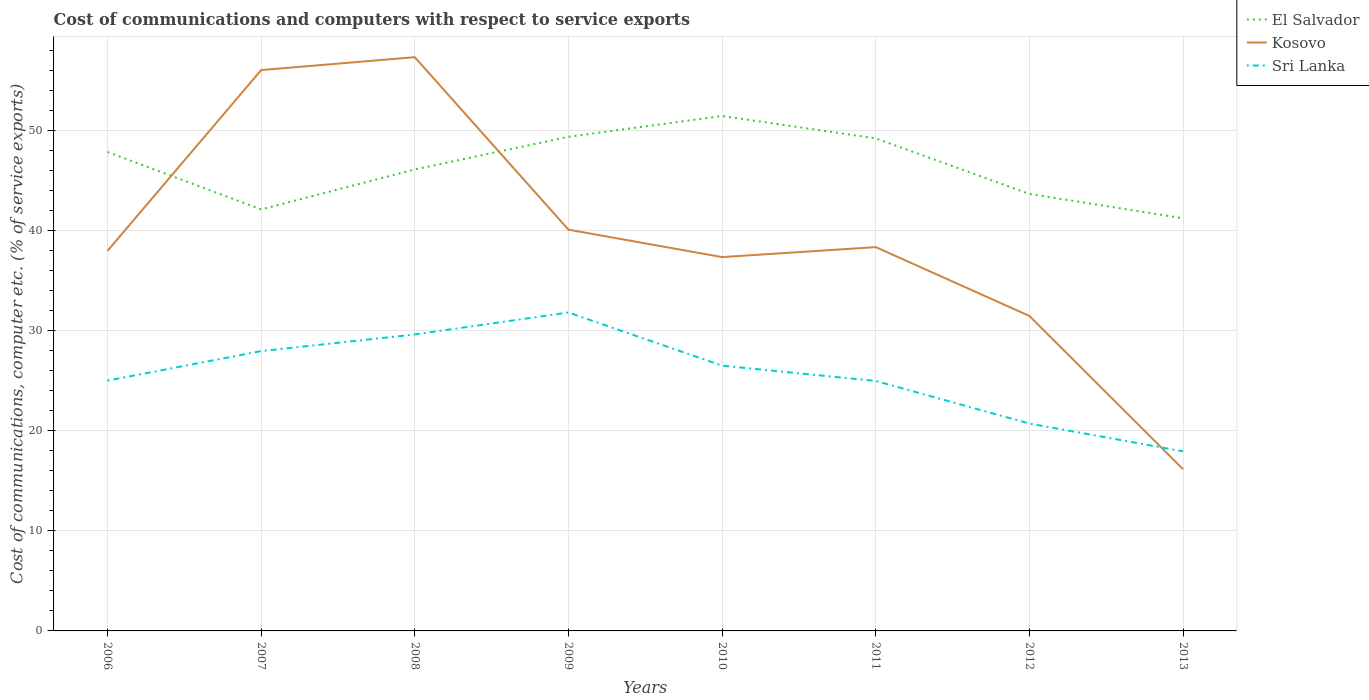Does the line corresponding to Sri Lanka intersect with the line corresponding to El Salvador?
Give a very brief answer. No. Across all years, what is the maximum cost of communications and computers in Sri Lanka?
Your response must be concise. 17.96. In which year was the cost of communications and computers in Kosovo maximum?
Offer a terse response. 2013. What is the total cost of communications and computers in El Salvador in the graph?
Give a very brief answer. 7.79. What is the difference between the highest and the second highest cost of communications and computers in Sri Lanka?
Ensure brevity in your answer.  13.88. What is the difference between the highest and the lowest cost of communications and computers in Kosovo?
Ensure brevity in your answer.  3. Is the cost of communications and computers in Kosovo strictly greater than the cost of communications and computers in El Salvador over the years?
Offer a terse response. No. Are the values on the major ticks of Y-axis written in scientific E-notation?
Provide a short and direct response. No. Does the graph contain any zero values?
Your answer should be compact. No. How many legend labels are there?
Ensure brevity in your answer.  3. How are the legend labels stacked?
Offer a terse response. Vertical. What is the title of the graph?
Provide a short and direct response. Cost of communications and computers with respect to service exports. Does "Oman" appear as one of the legend labels in the graph?
Your response must be concise. No. What is the label or title of the X-axis?
Provide a succinct answer. Years. What is the label or title of the Y-axis?
Your response must be concise. Cost of communications, computer etc. (% of service exports). What is the Cost of communications, computer etc. (% of service exports) in El Salvador in 2006?
Offer a very short reply. 47.89. What is the Cost of communications, computer etc. (% of service exports) in Kosovo in 2006?
Your answer should be compact. 38. What is the Cost of communications, computer etc. (% of service exports) in Sri Lanka in 2006?
Provide a succinct answer. 25.03. What is the Cost of communications, computer etc. (% of service exports) of El Salvador in 2007?
Give a very brief answer. 42.15. What is the Cost of communications, computer etc. (% of service exports) of Kosovo in 2007?
Provide a succinct answer. 56.09. What is the Cost of communications, computer etc. (% of service exports) in Sri Lanka in 2007?
Provide a short and direct response. 27.98. What is the Cost of communications, computer etc. (% of service exports) of El Salvador in 2008?
Your answer should be compact. 46.15. What is the Cost of communications, computer etc. (% of service exports) of Kosovo in 2008?
Ensure brevity in your answer.  57.37. What is the Cost of communications, computer etc. (% of service exports) of Sri Lanka in 2008?
Provide a succinct answer. 29.64. What is the Cost of communications, computer etc. (% of service exports) in El Salvador in 2009?
Offer a very short reply. 49.41. What is the Cost of communications, computer etc. (% of service exports) in Kosovo in 2009?
Your answer should be very brief. 40.12. What is the Cost of communications, computer etc. (% of service exports) of Sri Lanka in 2009?
Your response must be concise. 31.84. What is the Cost of communications, computer etc. (% of service exports) in El Salvador in 2010?
Provide a short and direct response. 51.49. What is the Cost of communications, computer etc. (% of service exports) of Kosovo in 2010?
Ensure brevity in your answer.  37.38. What is the Cost of communications, computer etc. (% of service exports) in Sri Lanka in 2010?
Provide a succinct answer. 26.53. What is the Cost of communications, computer etc. (% of service exports) of El Salvador in 2011?
Keep it short and to the point. 49.26. What is the Cost of communications, computer etc. (% of service exports) in Kosovo in 2011?
Make the answer very short. 38.38. What is the Cost of communications, computer etc. (% of service exports) of Sri Lanka in 2011?
Provide a succinct answer. 25. What is the Cost of communications, computer etc. (% of service exports) in El Salvador in 2012?
Provide a short and direct response. 43.7. What is the Cost of communications, computer etc. (% of service exports) of Kosovo in 2012?
Your answer should be compact. 31.5. What is the Cost of communications, computer etc. (% of service exports) of Sri Lanka in 2012?
Provide a short and direct response. 20.73. What is the Cost of communications, computer etc. (% of service exports) of El Salvador in 2013?
Give a very brief answer. 41.27. What is the Cost of communications, computer etc. (% of service exports) of Kosovo in 2013?
Ensure brevity in your answer.  16.17. What is the Cost of communications, computer etc. (% of service exports) of Sri Lanka in 2013?
Provide a succinct answer. 17.96. Across all years, what is the maximum Cost of communications, computer etc. (% of service exports) in El Salvador?
Your response must be concise. 51.49. Across all years, what is the maximum Cost of communications, computer etc. (% of service exports) in Kosovo?
Offer a very short reply. 57.37. Across all years, what is the maximum Cost of communications, computer etc. (% of service exports) in Sri Lanka?
Keep it short and to the point. 31.84. Across all years, what is the minimum Cost of communications, computer etc. (% of service exports) of El Salvador?
Ensure brevity in your answer.  41.27. Across all years, what is the minimum Cost of communications, computer etc. (% of service exports) in Kosovo?
Your answer should be very brief. 16.17. Across all years, what is the minimum Cost of communications, computer etc. (% of service exports) of Sri Lanka?
Offer a very short reply. 17.96. What is the total Cost of communications, computer etc. (% of service exports) of El Salvador in the graph?
Provide a short and direct response. 371.32. What is the total Cost of communications, computer etc. (% of service exports) in Kosovo in the graph?
Provide a short and direct response. 315.02. What is the total Cost of communications, computer etc. (% of service exports) of Sri Lanka in the graph?
Ensure brevity in your answer.  204.72. What is the difference between the Cost of communications, computer etc. (% of service exports) of El Salvador in 2006 and that in 2007?
Your response must be concise. 5.74. What is the difference between the Cost of communications, computer etc. (% of service exports) in Kosovo in 2006 and that in 2007?
Make the answer very short. -18.08. What is the difference between the Cost of communications, computer etc. (% of service exports) in Sri Lanka in 2006 and that in 2007?
Offer a terse response. -2.95. What is the difference between the Cost of communications, computer etc. (% of service exports) of El Salvador in 2006 and that in 2008?
Your response must be concise. 1.75. What is the difference between the Cost of communications, computer etc. (% of service exports) in Kosovo in 2006 and that in 2008?
Provide a short and direct response. -19.37. What is the difference between the Cost of communications, computer etc. (% of service exports) in Sri Lanka in 2006 and that in 2008?
Your answer should be compact. -4.61. What is the difference between the Cost of communications, computer etc. (% of service exports) of El Salvador in 2006 and that in 2009?
Offer a very short reply. -1.52. What is the difference between the Cost of communications, computer etc. (% of service exports) in Kosovo in 2006 and that in 2009?
Keep it short and to the point. -2.12. What is the difference between the Cost of communications, computer etc. (% of service exports) in Sri Lanka in 2006 and that in 2009?
Offer a terse response. -6.81. What is the difference between the Cost of communications, computer etc. (% of service exports) of El Salvador in 2006 and that in 2010?
Your answer should be very brief. -3.6. What is the difference between the Cost of communications, computer etc. (% of service exports) of Kosovo in 2006 and that in 2010?
Keep it short and to the point. 0.62. What is the difference between the Cost of communications, computer etc. (% of service exports) in Sri Lanka in 2006 and that in 2010?
Make the answer very short. -1.5. What is the difference between the Cost of communications, computer etc. (% of service exports) of El Salvador in 2006 and that in 2011?
Offer a terse response. -1.36. What is the difference between the Cost of communications, computer etc. (% of service exports) of Kosovo in 2006 and that in 2011?
Make the answer very short. -0.38. What is the difference between the Cost of communications, computer etc. (% of service exports) of Sri Lanka in 2006 and that in 2011?
Keep it short and to the point. 0.03. What is the difference between the Cost of communications, computer etc. (% of service exports) of El Salvador in 2006 and that in 2012?
Ensure brevity in your answer.  4.2. What is the difference between the Cost of communications, computer etc. (% of service exports) of Kosovo in 2006 and that in 2012?
Your response must be concise. 6.51. What is the difference between the Cost of communications, computer etc. (% of service exports) of Sri Lanka in 2006 and that in 2012?
Your response must be concise. 4.3. What is the difference between the Cost of communications, computer etc. (% of service exports) in El Salvador in 2006 and that in 2013?
Your answer should be very brief. 6.63. What is the difference between the Cost of communications, computer etc. (% of service exports) in Kosovo in 2006 and that in 2013?
Offer a very short reply. 21.83. What is the difference between the Cost of communications, computer etc. (% of service exports) in Sri Lanka in 2006 and that in 2013?
Your response must be concise. 7.07. What is the difference between the Cost of communications, computer etc. (% of service exports) in El Salvador in 2007 and that in 2008?
Your response must be concise. -4. What is the difference between the Cost of communications, computer etc. (% of service exports) of Kosovo in 2007 and that in 2008?
Your response must be concise. -1.29. What is the difference between the Cost of communications, computer etc. (% of service exports) of Sri Lanka in 2007 and that in 2008?
Offer a terse response. -1.66. What is the difference between the Cost of communications, computer etc. (% of service exports) in El Salvador in 2007 and that in 2009?
Keep it short and to the point. -7.26. What is the difference between the Cost of communications, computer etc. (% of service exports) of Kosovo in 2007 and that in 2009?
Your response must be concise. 15.96. What is the difference between the Cost of communications, computer etc. (% of service exports) of Sri Lanka in 2007 and that in 2009?
Your answer should be very brief. -3.86. What is the difference between the Cost of communications, computer etc. (% of service exports) in El Salvador in 2007 and that in 2010?
Make the answer very short. -9.34. What is the difference between the Cost of communications, computer etc. (% of service exports) of Kosovo in 2007 and that in 2010?
Offer a very short reply. 18.7. What is the difference between the Cost of communications, computer etc. (% of service exports) in Sri Lanka in 2007 and that in 2010?
Give a very brief answer. 1.46. What is the difference between the Cost of communications, computer etc. (% of service exports) of El Salvador in 2007 and that in 2011?
Offer a very short reply. -7.11. What is the difference between the Cost of communications, computer etc. (% of service exports) in Kosovo in 2007 and that in 2011?
Offer a very short reply. 17.7. What is the difference between the Cost of communications, computer etc. (% of service exports) in Sri Lanka in 2007 and that in 2011?
Your answer should be compact. 2.99. What is the difference between the Cost of communications, computer etc. (% of service exports) of El Salvador in 2007 and that in 2012?
Give a very brief answer. -1.55. What is the difference between the Cost of communications, computer etc. (% of service exports) in Kosovo in 2007 and that in 2012?
Your response must be concise. 24.59. What is the difference between the Cost of communications, computer etc. (% of service exports) in Sri Lanka in 2007 and that in 2012?
Your answer should be compact. 7.25. What is the difference between the Cost of communications, computer etc. (% of service exports) in El Salvador in 2007 and that in 2013?
Offer a very short reply. 0.88. What is the difference between the Cost of communications, computer etc. (% of service exports) of Kosovo in 2007 and that in 2013?
Your answer should be compact. 39.91. What is the difference between the Cost of communications, computer etc. (% of service exports) of Sri Lanka in 2007 and that in 2013?
Your response must be concise. 10.02. What is the difference between the Cost of communications, computer etc. (% of service exports) in El Salvador in 2008 and that in 2009?
Keep it short and to the point. -3.26. What is the difference between the Cost of communications, computer etc. (% of service exports) of Kosovo in 2008 and that in 2009?
Keep it short and to the point. 17.25. What is the difference between the Cost of communications, computer etc. (% of service exports) in Sri Lanka in 2008 and that in 2009?
Offer a very short reply. -2.2. What is the difference between the Cost of communications, computer etc. (% of service exports) in El Salvador in 2008 and that in 2010?
Your answer should be very brief. -5.35. What is the difference between the Cost of communications, computer etc. (% of service exports) in Kosovo in 2008 and that in 2010?
Your answer should be compact. 19.99. What is the difference between the Cost of communications, computer etc. (% of service exports) in Sri Lanka in 2008 and that in 2010?
Make the answer very short. 3.12. What is the difference between the Cost of communications, computer etc. (% of service exports) of El Salvador in 2008 and that in 2011?
Provide a succinct answer. -3.11. What is the difference between the Cost of communications, computer etc. (% of service exports) of Kosovo in 2008 and that in 2011?
Ensure brevity in your answer.  18.99. What is the difference between the Cost of communications, computer etc. (% of service exports) of Sri Lanka in 2008 and that in 2011?
Keep it short and to the point. 4.65. What is the difference between the Cost of communications, computer etc. (% of service exports) in El Salvador in 2008 and that in 2012?
Your response must be concise. 2.45. What is the difference between the Cost of communications, computer etc. (% of service exports) of Kosovo in 2008 and that in 2012?
Offer a very short reply. 25.88. What is the difference between the Cost of communications, computer etc. (% of service exports) of Sri Lanka in 2008 and that in 2012?
Your response must be concise. 8.91. What is the difference between the Cost of communications, computer etc. (% of service exports) in El Salvador in 2008 and that in 2013?
Keep it short and to the point. 4.88. What is the difference between the Cost of communications, computer etc. (% of service exports) of Kosovo in 2008 and that in 2013?
Ensure brevity in your answer.  41.2. What is the difference between the Cost of communications, computer etc. (% of service exports) of Sri Lanka in 2008 and that in 2013?
Offer a terse response. 11.68. What is the difference between the Cost of communications, computer etc. (% of service exports) of El Salvador in 2009 and that in 2010?
Provide a succinct answer. -2.08. What is the difference between the Cost of communications, computer etc. (% of service exports) of Kosovo in 2009 and that in 2010?
Ensure brevity in your answer.  2.74. What is the difference between the Cost of communications, computer etc. (% of service exports) in Sri Lanka in 2009 and that in 2010?
Your response must be concise. 5.32. What is the difference between the Cost of communications, computer etc. (% of service exports) of El Salvador in 2009 and that in 2011?
Provide a succinct answer. 0.15. What is the difference between the Cost of communications, computer etc. (% of service exports) of Kosovo in 2009 and that in 2011?
Keep it short and to the point. 1.74. What is the difference between the Cost of communications, computer etc. (% of service exports) of Sri Lanka in 2009 and that in 2011?
Your answer should be compact. 6.85. What is the difference between the Cost of communications, computer etc. (% of service exports) of El Salvador in 2009 and that in 2012?
Provide a short and direct response. 5.71. What is the difference between the Cost of communications, computer etc. (% of service exports) of Kosovo in 2009 and that in 2012?
Provide a short and direct response. 8.63. What is the difference between the Cost of communications, computer etc. (% of service exports) of Sri Lanka in 2009 and that in 2012?
Your answer should be very brief. 11.11. What is the difference between the Cost of communications, computer etc. (% of service exports) in El Salvador in 2009 and that in 2013?
Give a very brief answer. 8.14. What is the difference between the Cost of communications, computer etc. (% of service exports) of Kosovo in 2009 and that in 2013?
Offer a very short reply. 23.95. What is the difference between the Cost of communications, computer etc. (% of service exports) of Sri Lanka in 2009 and that in 2013?
Provide a succinct answer. 13.88. What is the difference between the Cost of communications, computer etc. (% of service exports) of El Salvador in 2010 and that in 2011?
Provide a short and direct response. 2.24. What is the difference between the Cost of communications, computer etc. (% of service exports) in Kosovo in 2010 and that in 2011?
Offer a terse response. -1. What is the difference between the Cost of communications, computer etc. (% of service exports) in Sri Lanka in 2010 and that in 2011?
Give a very brief answer. 1.53. What is the difference between the Cost of communications, computer etc. (% of service exports) in El Salvador in 2010 and that in 2012?
Offer a terse response. 7.79. What is the difference between the Cost of communications, computer etc. (% of service exports) of Kosovo in 2010 and that in 2012?
Make the answer very short. 5.89. What is the difference between the Cost of communications, computer etc. (% of service exports) of Sri Lanka in 2010 and that in 2012?
Your answer should be very brief. 5.79. What is the difference between the Cost of communications, computer etc. (% of service exports) of El Salvador in 2010 and that in 2013?
Keep it short and to the point. 10.23. What is the difference between the Cost of communications, computer etc. (% of service exports) of Kosovo in 2010 and that in 2013?
Your answer should be very brief. 21.21. What is the difference between the Cost of communications, computer etc. (% of service exports) of Sri Lanka in 2010 and that in 2013?
Provide a succinct answer. 8.57. What is the difference between the Cost of communications, computer etc. (% of service exports) in El Salvador in 2011 and that in 2012?
Your answer should be compact. 5.56. What is the difference between the Cost of communications, computer etc. (% of service exports) of Kosovo in 2011 and that in 2012?
Ensure brevity in your answer.  6.88. What is the difference between the Cost of communications, computer etc. (% of service exports) of Sri Lanka in 2011 and that in 2012?
Keep it short and to the point. 4.26. What is the difference between the Cost of communications, computer etc. (% of service exports) of El Salvador in 2011 and that in 2013?
Your answer should be very brief. 7.99. What is the difference between the Cost of communications, computer etc. (% of service exports) in Kosovo in 2011 and that in 2013?
Offer a very short reply. 22.21. What is the difference between the Cost of communications, computer etc. (% of service exports) in Sri Lanka in 2011 and that in 2013?
Offer a terse response. 7.04. What is the difference between the Cost of communications, computer etc. (% of service exports) of El Salvador in 2012 and that in 2013?
Offer a very short reply. 2.43. What is the difference between the Cost of communications, computer etc. (% of service exports) of Kosovo in 2012 and that in 2013?
Give a very brief answer. 15.32. What is the difference between the Cost of communications, computer etc. (% of service exports) of Sri Lanka in 2012 and that in 2013?
Offer a terse response. 2.77. What is the difference between the Cost of communications, computer etc. (% of service exports) in El Salvador in 2006 and the Cost of communications, computer etc. (% of service exports) in Kosovo in 2007?
Offer a very short reply. -8.19. What is the difference between the Cost of communications, computer etc. (% of service exports) of El Salvador in 2006 and the Cost of communications, computer etc. (% of service exports) of Sri Lanka in 2007?
Provide a short and direct response. 19.91. What is the difference between the Cost of communications, computer etc. (% of service exports) of Kosovo in 2006 and the Cost of communications, computer etc. (% of service exports) of Sri Lanka in 2007?
Offer a terse response. 10.02. What is the difference between the Cost of communications, computer etc. (% of service exports) in El Salvador in 2006 and the Cost of communications, computer etc. (% of service exports) in Kosovo in 2008?
Your answer should be very brief. -9.48. What is the difference between the Cost of communications, computer etc. (% of service exports) of El Salvador in 2006 and the Cost of communications, computer etc. (% of service exports) of Sri Lanka in 2008?
Your response must be concise. 18.25. What is the difference between the Cost of communications, computer etc. (% of service exports) in Kosovo in 2006 and the Cost of communications, computer etc. (% of service exports) in Sri Lanka in 2008?
Your answer should be compact. 8.36. What is the difference between the Cost of communications, computer etc. (% of service exports) in El Salvador in 2006 and the Cost of communications, computer etc. (% of service exports) in Kosovo in 2009?
Provide a succinct answer. 7.77. What is the difference between the Cost of communications, computer etc. (% of service exports) of El Salvador in 2006 and the Cost of communications, computer etc. (% of service exports) of Sri Lanka in 2009?
Make the answer very short. 16.05. What is the difference between the Cost of communications, computer etc. (% of service exports) of Kosovo in 2006 and the Cost of communications, computer etc. (% of service exports) of Sri Lanka in 2009?
Offer a very short reply. 6.16. What is the difference between the Cost of communications, computer etc. (% of service exports) in El Salvador in 2006 and the Cost of communications, computer etc. (% of service exports) in Kosovo in 2010?
Make the answer very short. 10.51. What is the difference between the Cost of communications, computer etc. (% of service exports) in El Salvador in 2006 and the Cost of communications, computer etc. (% of service exports) in Sri Lanka in 2010?
Provide a short and direct response. 21.37. What is the difference between the Cost of communications, computer etc. (% of service exports) of Kosovo in 2006 and the Cost of communications, computer etc. (% of service exports) of Sri Lanka in 2010?
Your answer should be compact. 11.48. What is the difference between the Cost of communications, computer etc. (% of service exports) in El Salvador in 2006 and the Cost of communications, computer etc. (% of service exports) in Kosovo in 2011?
Offer a terse response. 9.51. What is the difference between the Cost of communications, computer etc. (% of service exports) in El Salvador in 2006 and the Cost of communications, computer etc. (% of service exports) in Sri Lanka in 2011?
Ensure brevity in your answer.  22.9. What is the difference between the Cost of communications, computer etc. (% of service exports) in Kosovo in 2006 and the Cost of communications, computer etc. (% of service exports) in Sri Lanka in 2011?
Offer a very short reply. 13.01. What is the difference between the Cost of communications, computer etc. (% of service exports) of El Salvador in 2006 and the Cost of communications, computer etc. (% of service exports) of Kosovo in 2012?
Provide a succinct answer. 16.4. What is the difference between the Cost of communications, computer etc. (% of service exports) of El Salvador in 2006 and the Cost of communications, computer etc. (% of service exports) of Sri Lanka in 2012?
Offer a terse response. 27.16. What is the difference between the Cost of communications, computer etc. (% of service exports) in Kosovo in 2006 and the Cost of communications, computer etc. (% of service exports) in Sri Lanka in 2012?
Your response must be concise. 17.27. What is the difference between the Cost of communications, computer etc. (% of service exports) of El Salvador in 2006 and the Cost of communications, computer etc. (% of service exports) of Kosovo in 2013?
Offer a very short reply. 31.72. What is the difference between the Cost of communications, computer etc. (% of service exports) in El Salvador in 2006 and the Cost of communications, computer etc. (% of service exports) in Sri Lanka in 2013?
Provide a short and direct response. 29.93. What is the difference between the Cost of communications, computer etc. (% of service exports) in Kosovo in 2006 and the Cost of communications, computer etc. (% of service exports) in Sri Lanka in 2013?
Make the answer very short. 20.04. What is the difference between the Cost of communications, computer etc. (% of service exports) of El Salvador in 2007 and the Cost of communications, computer etc. (% of service exports) of Kosovo in 2008?
Keep it short and to the point. -15.22. What is the difference between the Cost of communications, computer etc. (% of service exports) in El Salvador in 2007 and the Cost of communications, computer etc. (% of service exports) in Sri Lanka in 2008?
Keep it short and to the point. 12.51. What is the difference between the Cost of communications, computer etc. (% of service exports) of Kosovo in 2007 and the Cost of communications, computer etc. (% of service exports) of Sri Lanka in 2008?
Your response must be concise. 26.44. What is the difference between the Cost of communications, computer etc. (% of service exports) of El Salvador in 2007 and the Cost of communications, computer etc. (% of service exports) of Kosovo in 2009?
Offer a very short reply. 2.03. What is the difference between the Cost of communications, computer etc. (% of service exports) in El Salvador in 2007 and the Cost of communications, computer etc. (% of service exports) in Sri Lanka in 2009?
Provide a short and direct response. 10.31. What is the difference between the Cost of communications, computer etc. (% of service exports) in Kosovo in 2007 and the Cost of communications, computer etc. (% of service exports) in Sri Lanka in 2009?
Offer a terse response. 24.24. What is the difference between the Cost of communications, computer etc. (% of service exports) in El Salvador in 2007 and the Cost of communications, computer etc. (% of service exports) in Kosovo in 2010?
Keep it short and to the point. 4.77. What is the difference between the Cost of communications, computer etc. (% of service exports) of El Salvador in 2007 and the Cost of communications, computer etc. (% of service exports) of Sri Lanka in 2010?
Ensure brevity in your answer.  15.62. What is the difference between the Cost of communications, computer etc. (% of service exports) in Kosovo in 2007 and the Cost of communications, computer etc. (% of service exports) in Sri Lanka in 2010?
Your answer should be very brief. 29.56. What is the difference between the Cost of communications, computer etc. (% of service exports) of El Salvador in 2007 and the Cost of communications, computer etc. (% of service exports) of Kosovo in 2011?
Your answer should be compact. 3.77. What is the difference between the Cost of communications, computer etc. (% of service exports) in El Salvador in 2007 and the Cost of communications, computer etc. (% of service exports) in Sri Lanka in 2011?
Keep it short and to the point. 17.15. What is the difference between the Cost of communications, computer etc. (% of service exports) of Kosovo in 2007 and the Cost of communications, computer etc. (% of service exports) of Sri Lanka in 2011?
Offer a terse response. 31.09. What is the difference between the Cost of communications, computer etc. (% of service exports) in El Salvador in 2007 and the Cost of communications, computer etc. (% of service exports) in Kosovo in 2012?
Offer a very short reply. 10.65. What is the difference between the Cost of communications, computer etc. (% of service exports) in El Salvador in 2007 and the Cost of communications, computer etc. (% of service exports) in Sri Lanka in 2012?
Offer a terse response. 21.42. What is the difference between the Cost of communications, computer etc. (% of service exports) of Kosovo in 2007 and the Cost of communications, computer etc. (% of service exports) of Sri Lanka in 2012?
Provide a short and direct response. 35.35. What is the difference between the Cost of communications, computer etc. (% of service exports) of El Salvador in 2007 and the Cost of communications, computer etc. (% of service exports) of Kosovo in 2013?
Your response must be concise. 25.98. What is the difference between the Cost of communications, computer etc. (% of service exports) of El Salvador in 2007 and the Cost of communications, computer etc. (% of service exports) of Sri Lanka in 2013?
Your answer should be compact. 24.19. What is the difference between the Cost of communications, computer etc. (% of service exports) of Kosovo in 2007 and the Cost of communications, computer etc. (% of service exports) of Sri Lanka in 2013?
Offer a very short reply. 38.12. What is the difference between the Cost of communications, computer etc. (% of service exports) in El Salvador in 2008 and the Cost of communications, computer etc. (% of service exports) in Kosovo in 2009?
Provide a succinct answer. 6.02. What is the difference between the Cost of communications, computer etc. (% of service exports) of El Salvador in 2008 and the Cost of communications, computer etc. (% of service exports) of Sri Lanka in 2009?
Provide a short and direct response. 14.3. What is the difference between the Cost of communications, computer etc. (% of service exports) of Kosovo in 2008 and the Cost of communications, computer etc. (% of service exports) of Sri Lanka in 2009?
Your answer should be compact. 25.53. What is the difference between the Cost of communications, computer etc. (% of service exports) in El Salvador in 2008 and the Cost of communications, computer etc. (% of service exports) in Kosovo in 2010?
Offer a terse response. 8.76. What is the difference between the Cost of communications, computer etc. (% of service exports) of El Salvador in 2008 and the Cost of communications, computer etc. (% of service exports) of Sri Lanka in 2010?
Offer a terse response. 19.62. What is the difference between the Cost of communications, computer etc. (% of service exports) of Kosovo in 2008 and the Cost of communications, computer etc. (% of service exports) of Sri Lanka in 2010?
Give a very brief answer. 30.85. What is the difference between the Cost of communications, computer etc. (% of service exports) in El Salvador in 2008 and the Cost of communications, computer etc. (% of service exports) in Kosovo in 2011?
Give a very brief answer. 7.77. What is the difference between the Cost of communications, computer etc. (% of service exports) of El Salvador in 2008 and the Cost of communications, computer etc. (% of service exports) of Sri Lanka in 2011?
Your response must be concise. 21.15. What is the difference between the Cost of communications, computer etc. (% of service exports) of Kosovo in 2008 and the Cost of communications, computer etc. (% of service exports) of Sri Lanka in 2011?
Keep it short and to the point. 32.38. What is the difference between the Cost of communications, computer etc. (% of service exports) of El Salvador in 2008 and the Cost of communications, computer etc. (% of service exports) of Kosovo in 2012?
Provide a short and direct response. 14.65. What is the difference between the Cost of communications, computer etc. (% of service exports) of El Salvador in 2008 and the Cost of communications, computer etc. (% of service exports) of Sri Lanka in 2012?
Your answer should be very brief. 25.41. What is the difference between the Cost of communications, computer etc. (% of service exports) in Kosovo in 2008 and the Cost of communications, computer etc. (% of service exports) in Sri Lanka in 2012?
Provide a short and direct response. 36.64. What is the difference between the Cost of communications, computer etc. (% of service exports) of El Salvador in 2008 and the Cost of communications, computer etc. (% of service exports) of Kosovo in 2013?
Provide a succinct answer. 29.97. What is the difference between the Cost of communications, computer etc. (% of service exports) of El Salvador in 2008 and the Cost of communications, computer etc. (% of service exports) of Sri Lanka in 2013?
Ensure brevity in your answer.  28.19. What is the difference between the Cost of communications, computer etc. (% of service exports) in Kosovo in 2008 and the Cost of communications, computer etc. (% of service exports) in Sri Lanka in 2013?
Make the answer very short. 39.41. What is the difference between the Cost of communications, computer etc. (% of service exports) in El Salvador in 2009 and the Cost of communications, computer etc. (% of service exports) in Kosovo in 2010?
Your answer should be compact. 12.03. What is the difference between the Cost of communications, computer etc. (% of service exports) of El Salvador in 2009 and the Cost of communications, computer etc. (% of service exports) of Sri Lanka in 2010?
Offer a terse response. 22.88. What is the difference between the Cost of communications, computer etc. (% of service exports) in Kosovo in 2009 and the Cost of communications, computer etc. (% of service exports) in Sri Lanka in 2010?
Provide a succinct answer. 13.6. What is the difference between the Cost of communications, computer etc. (% of service exports) in El Salvador in 2009 and the Cost of communications, computer etc. (% of service exports) in Kosovo in 2011?
Provide a short and direct response. 11.03. What is the difference between the Cost of communications, computer etc. (% of service exports) of El Salvador in 2009 and the Cost of communications, computer etc. (% of service exports) of Sri Lanka in 2011?
Offer a terse response. 24.41. What is the difference between the Cost of communications, computer etc. (% of service exports) of Kosovo in 2009 and the Cost of communications, computer etc. (% of service exports) of Sri Lanka in 2011?
Give a very brief answer. 15.13. What is the difference between the Cost of communications, computer etc. (% of service exports) of El Salvador in 2009 and the Cost of communications, computer etc. (% of service exports) of Kosovo in 2012?
Offer a very short reply. 17.91. What is the difference between the Cost of communications, computer etc. (% of service exports) in El Salvador in 2009 and the Cost of communications, computer etc. (% of service exports) in Sri Lanka in 2012?
Your answer should be compact. 28.68. What is the difference between the Cost of communications, computer etc. (% of service exports) in Kosovo in 2009 and the Cost of communications, computer etc. (% of service exports) in Sri Lanka in 2012?
Make the answer very short. 19.39. What is the difference between the Cost of communications, computer etc. (% of service exports) of El Salvador in 2009 and the Cost of communications, computer etc. (% of service exports) of Kosovo in 2013?
Offer a terse response. 33.24. What is the difference between the Cost of communications, computer etc. (% of service exports) of El Salvador in 2009 and the Cost of communications, computer etc. (% of service exports) of Sri Lanka in 2013?
Offer a terse response. 31.45. What is the difference between the Cost of communications, computer etc. (% of service exports) in Kosovo in 2009 and the Cost of communications, computer etc. (% of service exports) in Sri Lanka in 2013?
Provide a short and direct response. 22.16. What is the difference between the Cost of communications, computer etc. (% of service exports) in El Salvador in 2010 and the Cost of communications, computer etc. (% of service exports) in Kosovo in 2011?
Give a very brief answer. 13.11. What is the difference between the Cost of communications, computer etc. (% of service exports) in El Salvador in 2010 and the Cost of communications, computer etc. (% of service exports) in Sri Lanka in 2011?
Provide a short and direct response. 26.5. What is the difference between the Cost of communications, computer etc. (% of service exports) of Kosovo in 2010 and the Cost of communications, computer etc. (% of service exports) of Sri Lanka in 2011?
Provide a succinct answer. 12.39. What is the difference between the Cost of communications, computer etc. (% of service exports) of El Salvador in 2010 and the Cost of communications, computer etc. (% of service exports) of Kosovo in 2012?
Your answer should be compact. 20. What is the difference between the Cost of communications, computer etc. (% of service exports) in El Salvador in 2010 and the Cost of communications, computer etc. (% of service exports) in Sri Lanka in 2012?
Provide a short and direct response. 30.76. What is the difference between the Cost of communications, computer etc. (% of service exports) in Kosovo in 2010 and the Cost of communications, computer etc. (% of service exports) in Sri Lanka in 2012?
Your answer should be compact. 16.65. What is the difference between the Cost of communications, computer etc. (% of service exports) of El Salvador in 2010 and the Cost of communications, computer etc. (% of service exports) of Kosovo in 2013?
Make the answer very short. 35.32. What is the difference between the Cost of communications, computer etc. (% of service exports) of El Salvador in 2010 and the Cost of communications, computer etc. (% of service exports) of Sri Lanka in 2013?
Keep it short and to the point. 33.53. What is the difference between the Cost of communications, computer etc. (% of service exports) of Kosovo in 2010 and the Cost of communications, computer etc. (% of service exports) of Sri Lanka in 2013?
Give a very brief answer. 19.42. What is the difference between the Cost of communications, computer etc. (% of service exports) in El Salvador in 2011 and the Cost of communications, computer etc. (% of service exports) in Kosovo in 2012?
Your answer should be compact. 17.76. What is the difference between the Cost of communications, computer etc. (% of service exports) of El Salvador in 2011 and the Cost of communications, computer etc. (% of service exports) of Sri Lanka in 2012?
Provide a short and direct response. 28.52. What is the difference between the Cost of communications, computer etc. (% of service exports) in Kosovo in 2011 and the Cost of communications, computer etc. (% of service exports) in Sri Lanka in 2012?
Offer a terse response. 17.65. What is the difference between the Cost of communications, computer etc. (% of service exports) of El Salvador in 2011 and the Cost of communications, computer etc. (% of service exports) of Kosovo in 2013?
Give a very brief answer. 33.08. What is the difference between the Cost of communications, computer etc. (% of service exports) of El Salvador in 2011 and the Cost of communications, computer etc. (% of service exports) of Sri Lanka in 2013?
Make the answer very short. 31.3. What is the difference between the Cost of communications, computer etc. (% of service exports) of Kosovo in 2011 and the Cost of communications, computer etc. (% of service exports) of Sri Lanka in 2013?
Give a very brief answer. 20.42. What is the difference between the Cost of communications, computer etc. (% of service exports) in El Salvador in 2012 and the Cost of communications, computer etc. (% of service exports) in Kosovo in 2013?
Keep it short and to the point. 27.53. What is the difference between the Cost of communications, computer etc. (% of service exports) in El Salvador in 2012 and the Cost of communications, computer etc. (% of service exports) in Sri Lanka in 2013?
Provide a short and direct response. 25.74. What is the difference between the Cost of communications, computer etc. (% of service exports) in Kosovo in 2012 and the Cost of communications, computer etc. (% of service exports) in Sri Lanka in 2013?
Keep it short and to the point. 13.54. What is the average Cost of communications, computer etc. (% of service exports) of El Salvador per year?
Your response must be concise. 46.41. What is the average Cost of communications, computer etc. (% of service exports) in Kosovo per year?
Give a very brief answer. 39.38. What is the average Cost of communications, computer etc. (% of service exports) of Sri Lanka per year?
Provide a succinct answer. 25.59. In the year 2006, what is the difference between the Cost of communications, computer etc. (% of service exports) in El Salvador and Cost of communications, computer etc. (% of service exports) in Kosovo?
Your answer should be very brief. 9.89. In the year 2006, what is the difference between the Cost of communications, computer etc. (% of service exports) in El Salvador and Cost of communications, computer etc. (% of service exports) in Sri Lanka?
Make the answer very short. 22.87. In the year 2006, what is the difference between the Cost of communications, computer etc. (% of service exports) in Kosovo and Cost of communications, computer etc. (% of service exports) in Sri Lanka?
Keep it short and to the point. 12.97. In the year 2007, what is the difference between the Cost of communications, computer etc. (% of service exports) in El Salvador and Cost of communications, computer etc. (% of service exports) in Kosovo?
Ensure brevity in your answer.  -13.93. In the year 2007, what is the difference between the Cost of communications, computer etc. (% of service exports) in El Salvador and Cost of communications, computer etc. (% of service exports) in Sri Lanka?
Offer a terse response. 14.17. In the year 2007, what is the difference between the Cost of communications, computer etc. (% of service exports) in Kosovo and Cost of communications, computer etc. (% of service exports) in Sri Lanka?
Your response must be concise. 28.1. In the year 2008, what is the difference between the Cost of communications, computer etc. (% of service exports) of El Salvador and Cost of communications, computer etc. (% of service exports) of Kosovo?
Your response must be concise. -11.23. In the year 2008, what is the difference between the Cost of communications, computer etc. (% of service exports) of El Salvador and Cost of communications, computer etc. (% of service exports) of Sri Lanka?
Ensure brevity in your answer.  16.5. In the year 2008, what is the difference between the Cost of communications, computer etc. (% of service exports) in Kosovo and Cost of communications, computer etc. (% of service exports) in Sri Lanka?
Make the answer very short. 27.73. In the year 2009, what is the difference between the Cost of communications, computer etc. (% of service exports) in El Salvador and Cost of communications, computer etc. (% of service exports) in Kosovo?
Provide a succinct answer. 9.29. In the year 2009, what is the difference between the Cost of communications, computer etc. (% of service exports) in El Salvador and Cost of communications, computer etc. (% of service exports) in Sri Lanka?
Offer a very short reply. 17.57. In the year 2009, what is the difference between the Cost of communications, computer etc. (% of service exports) of Kosovo and Cost of communications, computer etc. (% of service exports) of Sri Lanka?
Keep it short and to the point. 8.28. In the year 2010, what is the difference between the Cost of communications, computer etc. (% of service exports) of El Salvador and Cost of communications, computer etc. (% of service exports) of Kosovo?
Provide a short and direct response. 14.11. In the year 2010, what is the difference between the Cost of communications, computer etc. (% of service exports) of El Salvador and Cost of communications, computer etc. (% of service exports) of Sri Lanka?
Provide a short and direct response. 24.97. In the year 2010, what is the difference between the Cost of communications, computer etc. (% of service exports) of Kosovo and Cost of communications, computer etc. (% of service exports) of Sri Lanka?
Provide a short and direct response. 10.86. In the year 2011, what is the difference between the Cost of communications, computer etc. (% of service exports) of El Salvador and Cost of communications, computer etc. (% of service exports) of Kosovo?
Provide a succinct answer. 10.88. In the year 2011, what is the difference between the Cost of communications, computer etc. (% of service exports) of El Salvador and Cost of communications, computer etc. (% of service exports) of Sri Lanka?
Make the answer very short. 24.26. In the year 2011, what is the difference between the Cost of communications, computer etc. (% of service exports) of Kosovo and Cost of communications, computer etc. (% of service exports) of Sri Lanka?
Keep it short and to the point. 13.38. In the year 2012, what is the difference between the Cost of communications, computer etc. (% of service exports) of El Salvador and Cost of communications, computer etc. (% of service exports) of Kosovo?
Your answer should be compact. 12.2. In the year 2012, what is the difference between the Cost of communications, computer etc. (% of service exports) of El Salvador and Cost of communications, computer etc. (% of service exports) of Sri Lanka?
Ensure brevity in your answer.  22.97. In the year 2012, what is the difference between the Cost of communications, computer etc. (% of service exports) in Kosovo and Cost of communications, computer etc. (% of service exports) in Sri Lanka?
Your answer should be compact. 10.76. In the year 2013, what is the difference between the Cost of communications, computer etc. (% of service exports) in El Salvador and Cost of communications, computer etc. (% of service exports) in Kosovo?
Your answer should be very brief. 25.09. In the year 2013, what is the difference between the Cost of communications, computer etc. (% of service exports) of El Salvador and Cost of communications, computer etc. (% of service exports) of Sri Lanka?
Offer a terse response. 23.31. In the year 2013, what is the difference between the Cost of communications, computer etc. (% of service exports) in Kosovo and Cost of communications, computer etc. (% of service exports) in Sri Lanka?
Provide a short and direct response. -1.79. What is the ratio of the Cost of communications, computer etc. (% of service exports) in El Salvador in 2006 to that in 2007?
Your answer should be compact. 1.14. What is the ratio of the Cost of communications, computer etc. (% of service exports) in Kosovo in 2006 to that in 2007?
Offer a terse response. 0.68. What is the ratio of the Cost of communications, computer etc. (% of service exports) in Sri Lanka in 2006 to that in 2007?
Provide a succinct answer. 0.89. What is the ratio of the Cost of communications, computer etc. (% of service exports) in El Salvador in 2006 to that in 2008?
Provide a short and direct response. 1.04. What is the ratio of the Cost of communications, computer etc. (% of service exports) in Kosovo in 2006 to that in 2008?
Give a very brief answer. 0.66. What is the ratio of the Cost of communications, computer etc. (% of service exports) of Sri Lanka in 2006 to that in 2008?
Keep it short and to the point. 0.84. What is the ratio of the Cost of communications, computer etc. (% of service exports) in El Salvador in 2006 to that in 2009?
Your response must be concise. 0.97. What is the ratio of the Cost of communications, computer etc. (% of service exports) in Kosovo in 2006 to that in 2009?
Provide a short and direct response. 0.95. What is the ratio of the Cost of communications, computer etc. (% of service exports) in Sri Lanka in 2006 to that in 2009?
Give a very brief answer. 0.79. What is the ratio of the Cost of communications, computer etc. (% of service exports) of El Salvador in 2006 to that in 2010?
Your answer should be compact. 0.93. What is the ratio of the Cost of communications, computer etc. (% of service exports) in Kosovo in 2006 to that in 2010?
Provide a short and direct response. 1.02. What is the ratio of the Cost of communications, computer etc. (% of service exports) of Sri Lanka in 2006 to that in 2010?
Offer a very short reply. 0.94. What is the ratio of the Cost of communications, computer etc. (% of service exports) of El Salvador in 2006 to that in 2011?
Your response must be concise. 0.97. What is the ratio of the Cost of communications, computer etc. (% of service exports) of Kosovo in 2006 to that in 2011?
Give a very brief answer. 0.99. What is the ratio of the Cost of communications, computer etc. (% of service exports) in El Salvador in 2006 to that in 2012?
Offer a very short reply. 1.1. What is the ratio of the Cost of communications, computer etc. (% of service exports) of Kosovo in 2006 to that in 2012?
Give a very brief answer. 1.21. What is the ratio of the Cost of communications, computer etc. (% of service exports) of Sri Lanka in 2006 to that in 2012?
Offer a terse response. 1.21. What is the ratio of the Cost of communications, computer etc. (% of service exports) in El Salvador in 2006 to that in 2013?
Offer a very short reply. 1.16. What is the ratio of the Cost of communications, computer etc. (% of service exports) of Kosovo in 2006 to that in 2013?
Your answer should be very brief. 2.35. What is the ratio of the Cost of communications, computer etc. (% of service exports) of Sri Lanka in 2006 to that in 2013?
Offer a very short reply. 1.39. What is the ratio of the Cost of communications, computer etc. (% of service exports) in El Salvador in 2007 to that in 2008?
Provide a succinct answer. 0.91. What is the ratio of the Cost of communications, computer etc. (% of service exports) in Kosovo in 2007 to that in 2008?
Your answer should be compact. 0.98. What is the ratio of the Cost of communications, computer etc. (% of service exports) of Sri Lanka in 2007 to that in 2008?
Keep it short and to the point. 0.94. What is the ratio of the Cost of communications, computer etc. (% of service exports) of El Salvador in 2007 to that in 2009?
Your response must be concise. 0.85. What is the ratio of the Cost of communications, computer etc. (% of service exports) of Kosovo in 2007 to that in 2009?
Your answer should be compact. 1.4. What is the ratio of the Cost of communications, computer etc. (% of service exports) in Sri Lanka in 2007 to that in 2009?
Your response must be concise. 0.88. What is the ratio of the Cost of communications, computer etc. (% of service exports) of El Salvador in 2007 to that in 2010?
Keep it short and to the point. 0.82. What is the ratio of the Cost of communications, computer etc. (% of service exports) of Kosovo in 2007 to that in 2010?
Provide a succinct answer. 1.5. What is the ratio of the Cost of communications, computer etc. (% of service exports) of Sri Lanka in 2007 to that in 2010?
Offer a very short reply. 1.05. What is the ratio of the Cost of communications, computer etc. (% of service exports) in El Salvador in 2007 to that in 2011?
Make the answer very short. 0.86. What is the ratio of the Cost of communications, computer etc. (% of service exports) in Kosovo in 2007 to that in 2011?
Provide a short and direct response. 1.46. What is the ratio of the Cost of communications, computer etc. (% of service exports) of Sri Lanka in 2007 to that in 2011?
Offer a very short reply. 1.12. What is the ratio of the Cost of communications, computer etc. (% of service exports) in El Salvador in 2007 to that in 2012?
Your response must be concise. 0.96. What is the ratio of the Cost of communications, computer etc. (% of service exports) of Kosovo in 2007 to that in 2012?
Make the answer very short. 1.78. What is the ratio of the Cost of communications, computer etc. (% of service exports) in Sri Lanka in 2007 to that in 2012?
Ensure brevity in your answer.  1.35. What is the ratio of the Cost of communications, computer etc. (% of service exports) in El Salvador in 2007 to that in 2013?
Give a very brief answer. 1.02. What is the ratio of the Cost of communications, computer etc. (% of service exports) in Kosovo in 2007 to that in 2013?
Provide a short and direct response. 3.47. What is the ratio of the Cost of communications, computer etc. (% of service exports) in Sri Lanka in 2007 to that in 2013?
Provide a succinct answer. 1.56. What is the ratio of the Cost of communications, computer etc. (% of service exports) of El Salvador in 2008 to that in 2009?
Make the answer very short. 0.93. What is the ratio of the Cost of communications, computer etc. (% of service exports) in Kosovo in 2008 to that in 2009?
Make the answer very short. 1.43. What is the ratio of the Cost of communications, computer etc. (% of service exports) of Sri Lanka in 2008 to that in 2009?
Give a very brief answer. 0.93. What is the ratio of the Cost of communications, computer etc. (% of service exports) in El Salvador in 2008 to that in 2010?
Your response must be concise. 0.9. What is the ratio of the Cost of communications, computer etc. (% of service exports) of Kosovo in 2008 to that in 2010?
Make the answer very short. 1.53. What is the ratio of the Cost of communications, computer etc. (% of service exports) of Sri Lanka in 2008 to that in 2010?
Your response must be concise. 1.12. What is the ratio of the Cost of communications, computer etc. (% of service exports) in El Salvador in 2008 to that in 2011?
Your response must be concise. 0.94. What is the ratio of the Cost of communications, computer etc. (% of service exports) of Kosovo in 2008 to that in 2011?
Ensure brevity in your answer.  1.49. What is the ratio of the Cost of communications, computer etc. (% of service exports) in Sri Lanka in 2008 to that in 2011?
Give a very brief answer. 1.19. What is the ratio of the Cost of communications, computer etc. (% of service exports) in El Salvador in 2008 to that in 2012?
Provide a short and direct response. 1.06. What is the ratio of the Cost of communications, computer etc. (% of service exports) in Kosovo in 2008 to that in 2012?
Provide a short and direct response. 1.82. What is the ratio of the Cost of communications, computer etc. (% of service exports) of Sri Lanka in 2008 to that in 2012?
Your answer should be compact. 1.43. What is the ratio of the Cost of communications, computer etc. (% of service exports) of El Salvador in 2008 to that in 2013?
Offer a very short reply. 1.12. What is the ratio of the Cost of communications, computer etc. (% of service exports) in Kosovo in 2008 to that in 2013?
Provide a short and direct response. 3.55. What is the ratio of the Cost of communications, computer etc. (% of service exports) in Sri Lanka in 2008 to that in 2013?
Ensure brevity in your answer.  1.65. What is the ratio of the Cost of communications, computer etc. (% of service exports) of El Salvador in 2009 to that in 2010?
Give a very brief answer. 0.96. What is the ratio of the Cost of communications, computer etc. (% of service exports) in Kosovo in 2009 to that in 2010?
Your response must be concise. 1.07. What is the ratio of the Cost of communications, computer etc. (% of service exports) of Sri Lanka in 2009 to that in 2010?
Your answer should be very brief. 1.2. What is the ratio of the Cost of communications, computer etc. (% of service exports) in Kosovo in 2009 to that in 2011?
Offer a very short reply. 1.05. What is the ratio of the Cost of communications, computer etc. (% of service exports) of Sri Lanka in 2009 to that in 2011?
Your response must be concise. 1.27. What is the ratio of the Cost of communications, computer etc. (% of service exports) of El Salvador in 2009 to that in 2012?
Offer a very short reply. 1.13. What is the ratio of the Cost of communications, computer etc. (% of service exports) of Kosovo in 2009 to that in 2012?
Give a very brief answer. 1.27. What is the ratio of the Cost of communications, computer etc. (% of service exports) in Sri Lanka in 2009 to that in 2012?
Keep it short and to the point. 1.54. What is the ratio of the Cost of communications, computer etc. (% of service exports) in El Salvador in 2009 to that in 2013?
Your answer should be compact. 1.2. What is the ratio of the Cost of communications, computer etc. (% of service exports) of Kosovo in 2009 to that in 2013?
Offer a very short reply. 2.48. What is the ratio of the Cost of communications, computer etc. (% of service exports) of Sri Lanka in 2009 to that in 2013?
Your response must be concise. 1.77. What is the ratio of the Cost of communications, computer etc. (% of service exports) of El Salvador in 2010 to that in 2011?
Make the answer very short. 1.05. What is the ratio of the Cost of communications, computer etc. (% of service exports) in Sri Lanka in 2010 to that in 2011?
Give a very brief answer. 1.06. What is the ratio of the Cost of communications, computer etc. (% of service exports) of El Salvador in 2010 to that in 2012?
Give a very brief answer. 1.18. What is the ratio of the Cost of communications, computer etc. (% of service exports) of Kosovo in 2010 to that in 2012?
Provide a succinct answer. 1.19. What is the ratio of the Cost of communications, computer etc. (% of service exports) in Sri Lanka in 2010 to that in 2012?
Ensure brevity in your answer.  1.28. What is the ratio of the Cost of communications, computer etc. (% of service exports) in El Salvador in 2010 to that in 2013?
Ensure brevity in your answer.  1.25. What is the ratio of the Cost of communications, computer etc. (% of service exports) of Kosovo in 2010 to that in 2013?
Keep it short and to the point. 2.31. What is the ratio of the Cost of communications, computer etc. (% of service exports) of Sri Lanka in 2010 to that in 2013?
Your answer should be very brief. 1.48. What is the ratio of the Cost of communications, computer etc. (% of service exports) of El Salvador in 2011 to that in 2012?
Keep it short and to the point. 1.13. What is the ratio of the Cost of communications, computer etc. (% of service exports) in Kosovo in 2011 to that in 2012?
Give a very brief answer. 1.22. What is the ratio of the Cost of communications, computer etc. (% of service exports) in Sri Lanka in 2011 to that in 2012?
Keep it short and to the point. 1.21. What is the ratio of the Cost of communications, computer etc. (% of service exports) of El Salvador in 2011 to that in 2013?
Provide a succinct answer. 1.19. What is the ratio of the Cost of communications, computer etc. (% of service exports) in Kosovo in 2011 to that in 2013?
Ensure brevity in your answer.  2.37. What is the ratio of the Cost of communications, computer etc. (% of service exports) in Sri Lanka in 2011 to that in 2013?
Offer a very short reply. 1.39. What is the ratio of the Cost of communications, computer etc. (% of service exports) of El Salvador in 2012 to that in 2013?
Make the answer very short. 1.06. What is the ratio of the Cost of communications, computer etc. (% of service exports) of Kosovo in 2012 to that in 2013?
Provide a succinct answer. 1.95. What is the ratio of the Cost of communications, computer etc. (% of service exports) in Sri Lanka in 2012 to that in 2013?
Keep it short and to the point. 1.15. What is the difference between the highest and the second highest Cost of communications, computer etc. (% of service exports) in El Salvador?
Your response must be concise. 2.08. What is the difference between the highest and the second highest Cost of communications, computer etc. (% of service exports) in Kosovo?
Make the answer very short. 1.29. What is the difference between the highest and the second highest Cost of communications, computer etc. (% of service exports) in Sri Lanka?
Offer a terse response. 2.2. What is the difference between the highest and the lowest Cost of communications, computer etc. (% of service exports) in El Salvador?
Provide a succinct answer. 10.23. What is the difference between the highest and the lowest Cost of communications, computer etc. (% of service exports) in Kosovo?
Make the answer very short. 41.2. What is the difference between the highest and the lowest Cost of communications, computer etc. (% of service exports) in Sri Lanka?
Offer a terse response. 13.88. 